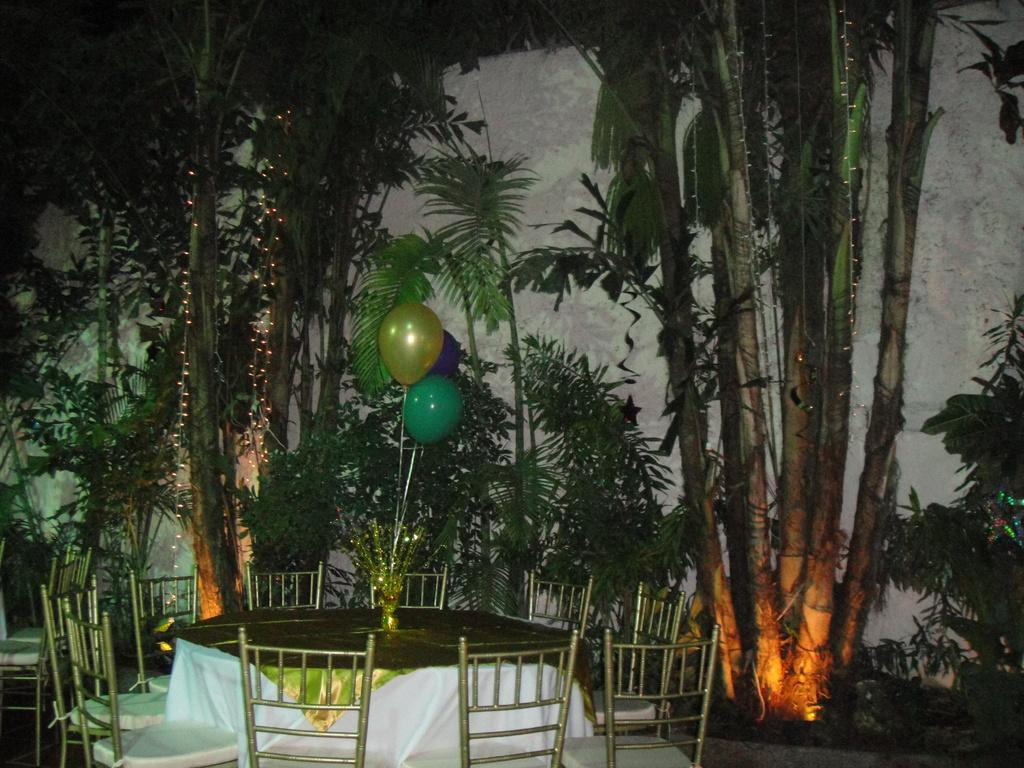What type of furniture is present in the image? There are chairs in the image. What is on the ground in the image? There is a table on the ground in the image. What material is present in the image? There is cloth in the image. What decorative items are present in the image? There are balloons in the image. What type of lighting is present in the image? There are lights in the image. What other objects can be seen in the image? There are some objects in the image. What can be seen in the background of the image? There is a wall and trees in the background of the image. How many snails are crawling on the table in the image? There are no snails present in the image. What type of truck can be seen in the background of the image? There is no truck present in the image; only a wall and trees can be seen in the background. 